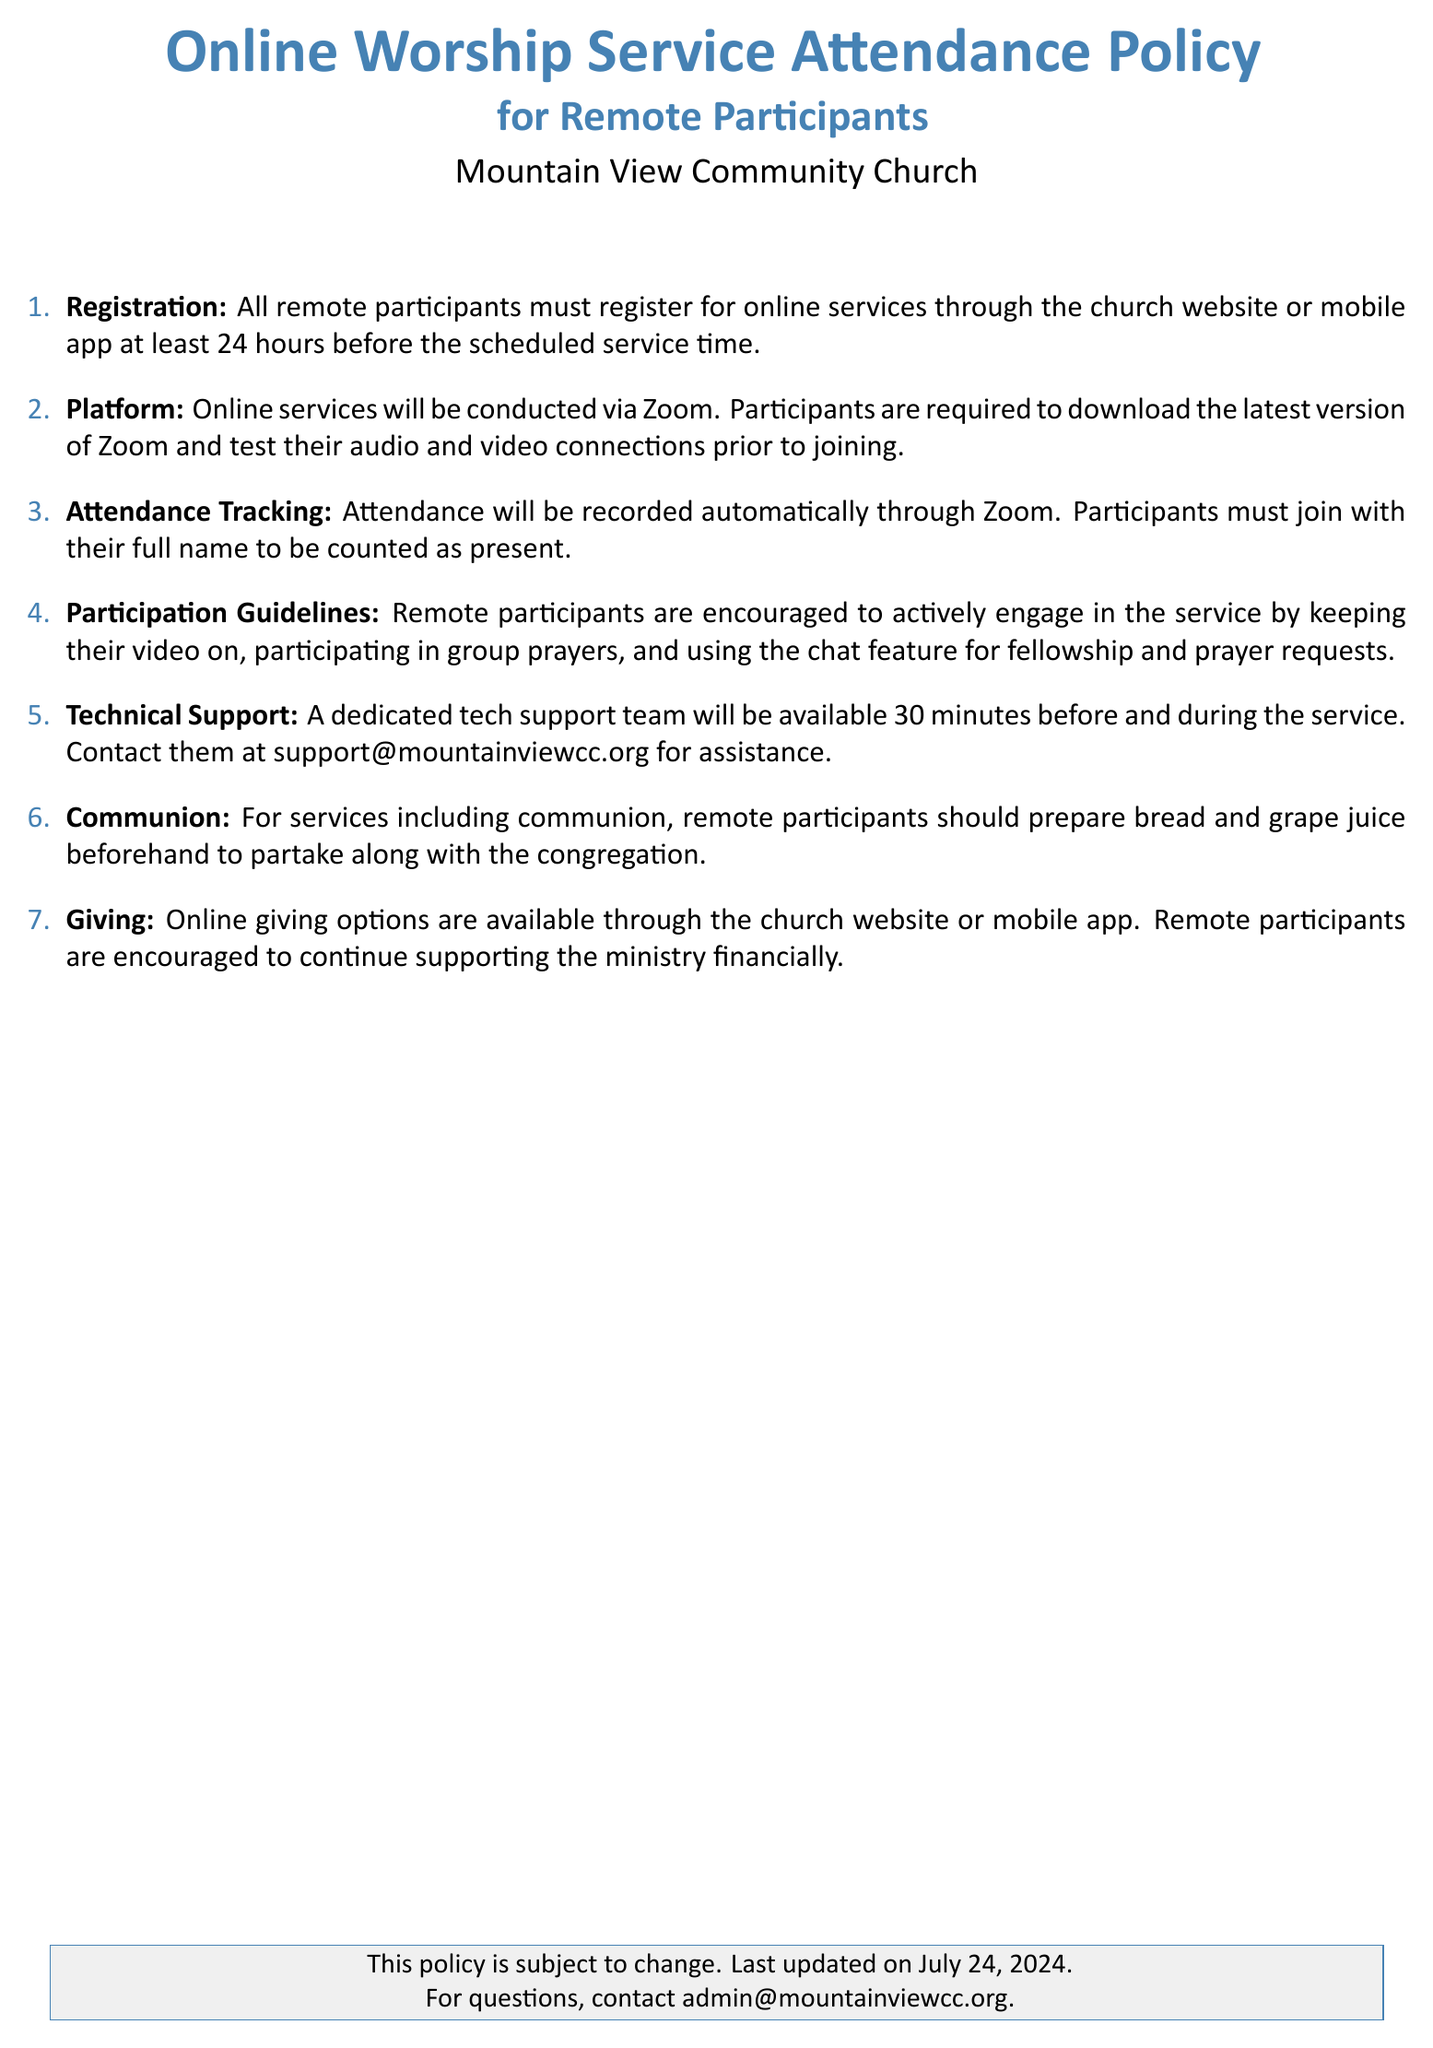What is the registration deadline for online services? The registration deadline is at least 24 hours before the scheduled service time.
Answer: 24 hours Which platform is used for the online services? The document states that online services will be conducted via Zoom.
Answer: Zoom How can participants receive technical support? Participants can contact the dedicated tech support team at support@mountainviewcc.org.
Answer: support@mountainviewcc.org What should remote participants prepare for communion? The document states that remote participants should prepare bread and grape juice beforehand.
Answer: bread and grape juice What is required for attendance tracking during the service? Participants must join with their full name to be counted as present.
Answer: full name Are remote participants encouraged to turn on their video? The participation guidelines encourage remote participants to keep their video on.
Answer: Yes What is the main purpose of the attendance policy? The main purpose is to outline guidelines for remote participants attending online worship services.
Answer: guidelines for remote participants How far in advance should remote participants register? Remote participants must register at least 24 hours before the service starts.
Answer: 24 hours 